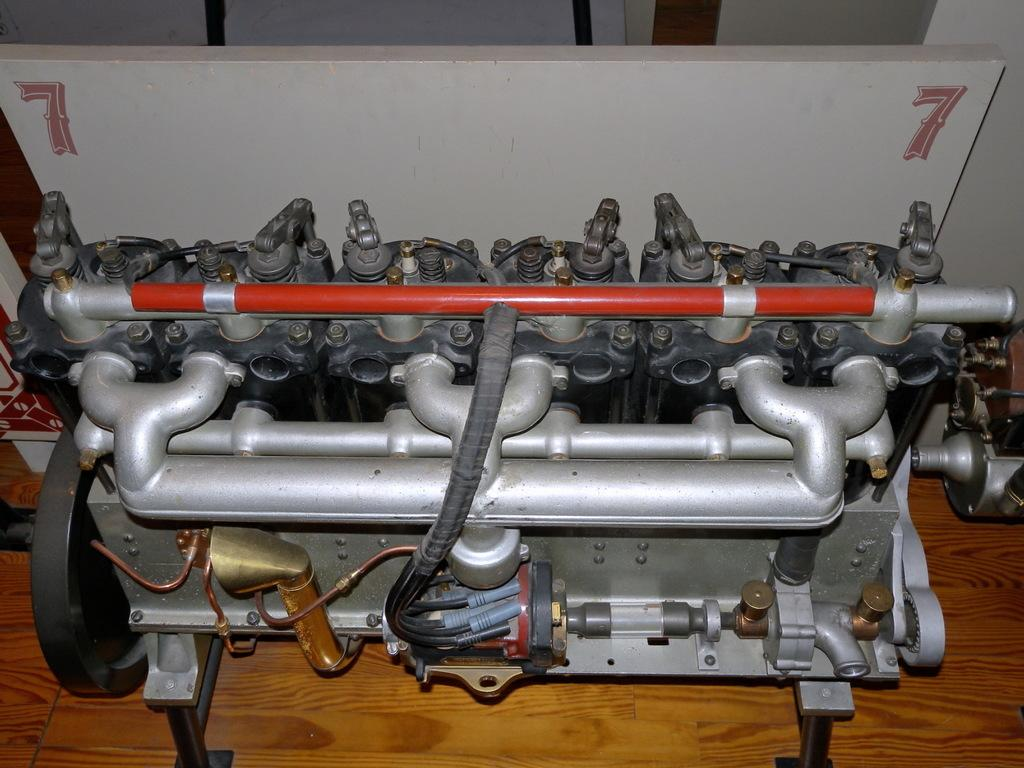What type of equipment can be seen in the image? There is machinery equipment in the image. What color is the board in the background? The color board in the background is white. How would you describe the overall color scheme of the background? The background is predominantly white. What type of flooring is visible at the bottom of the picture? There is a wooden floor at the bottom of the picture. How many fingers can be seen on the machinery equipment in the image? There are no fingers visible on the machinery equipment in the image. Is there a bomb present in the image? There is no bomb present in the image. 